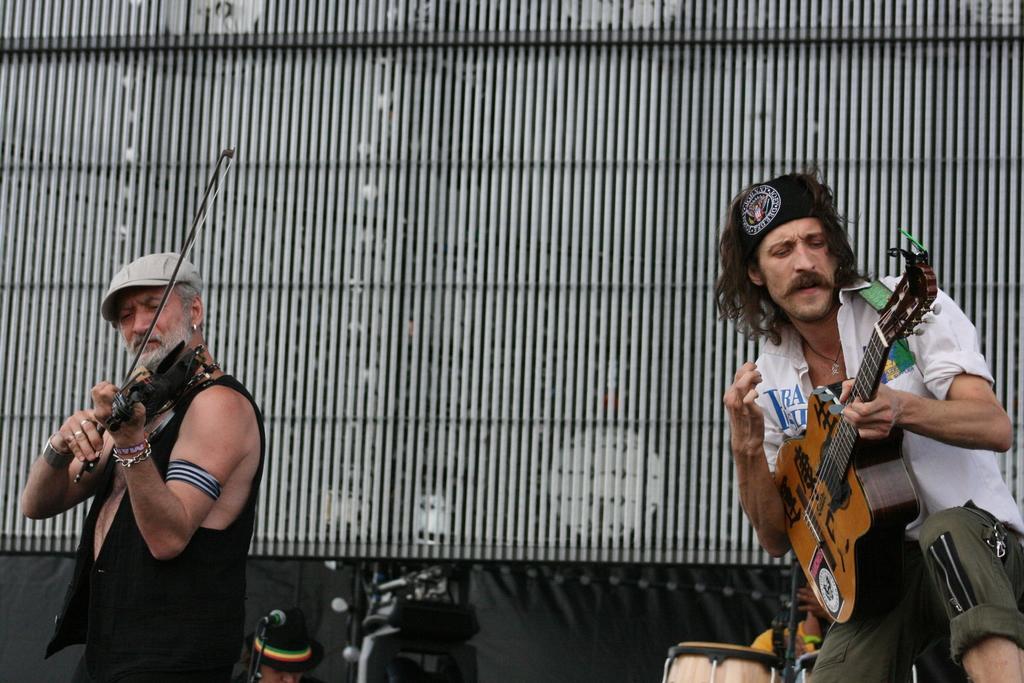Could you give a brief overview of what you see in this image? The image consists of two old men playing guitar ,in background there is drum kit. 